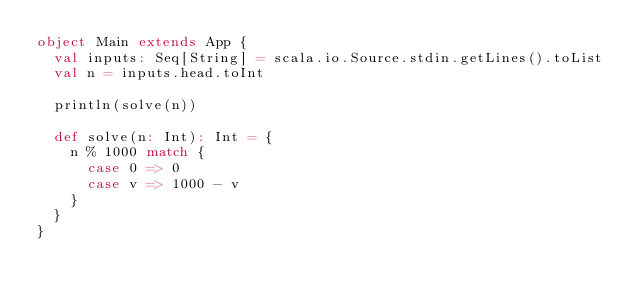<code> <loc_0><loc_0><loc_500><loc_500><_Scala_>object Main extends App {
  val inputs: Seq[String] = scala.io.Source.stdin.getLines().toList
  val n = inputs.head.toInt

  println(solve(n))

  def solve(n: Int): Int = {
    n % 1000 match {
      case 0 => 0
      case v => 1000 - v
    }
  }
}</code> 